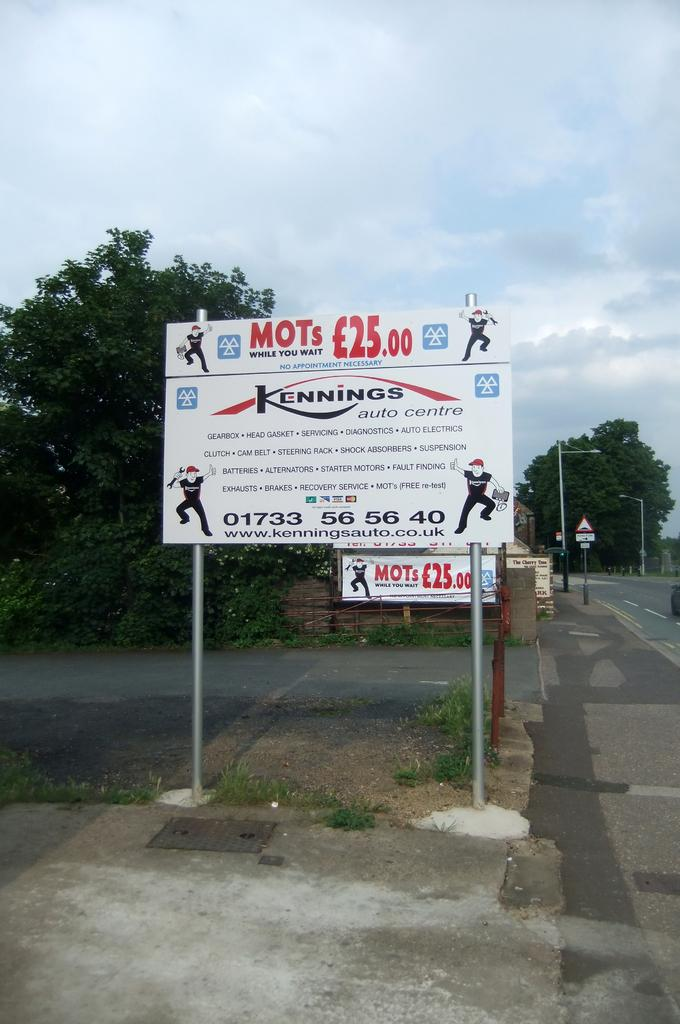What is the main feature of the image? There is a road in the image. What else can be seen along the road? There are boards and poles with lights visible in the image. What can be seen in the background of the image? There are trees and the sky visible in the background of the image. How many orange jellyfish can be seen swimming in the image? There are no orange jellyfish present in the image; it features a road, boards, poles with lights, trees, and the sky. Are there any cows grazing near the road in the image? There are no cows visible in the image. 